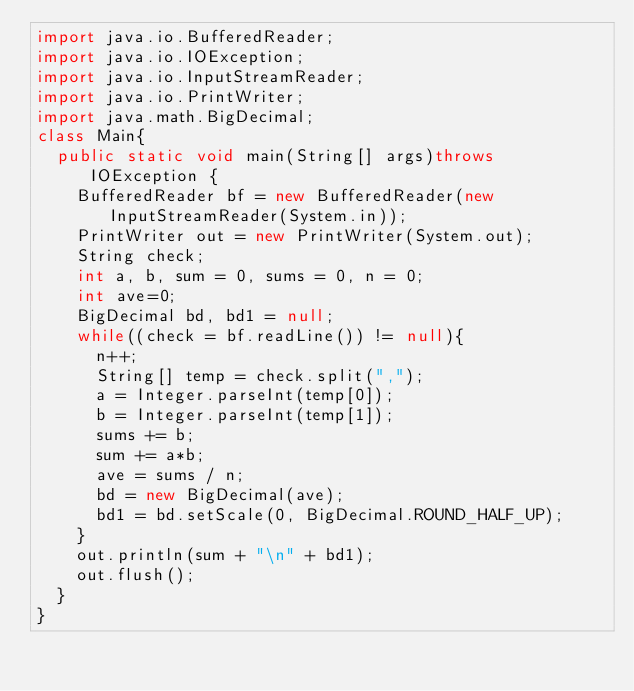<code> <loc_0><loc_0><loc_500><loc_500><_Java_>import java.io.BufferedReader;
import java.io.IOException;
import java.io.InputStreamReader;
import java.io.PrintWriter;
import java.math.BigDecimal;
class Main{
	public static void main(String[] args)throws IOException {
		BufferedReader bf = new BufferedReader(new InputStreamReader(System.in));
		PrintWriter out = new PrintWriter(System.out);
		String check;
		int a, b, sum = 0, sums = 0, n = 0;
		int ave=0;
		BigDecimal bd, bd1 = null;
		while((check = bf.readLine()) != null){
			n++;
			String[] temp = check.split(",");
			a = Integer.parseInt(temp[0]);
			b = Integer.parseInt(temp[1]);
			sums += b;
			sum += a*b;
			ave = sums / n;
			bd = new BigDecimal(ave);
			bd1 = bd.setScale(0, BigDecimal.ROUND_HALF_UP);
		}
		out.println(sum + "\n" + bd1);
		out.flush();
	}
}</code> 